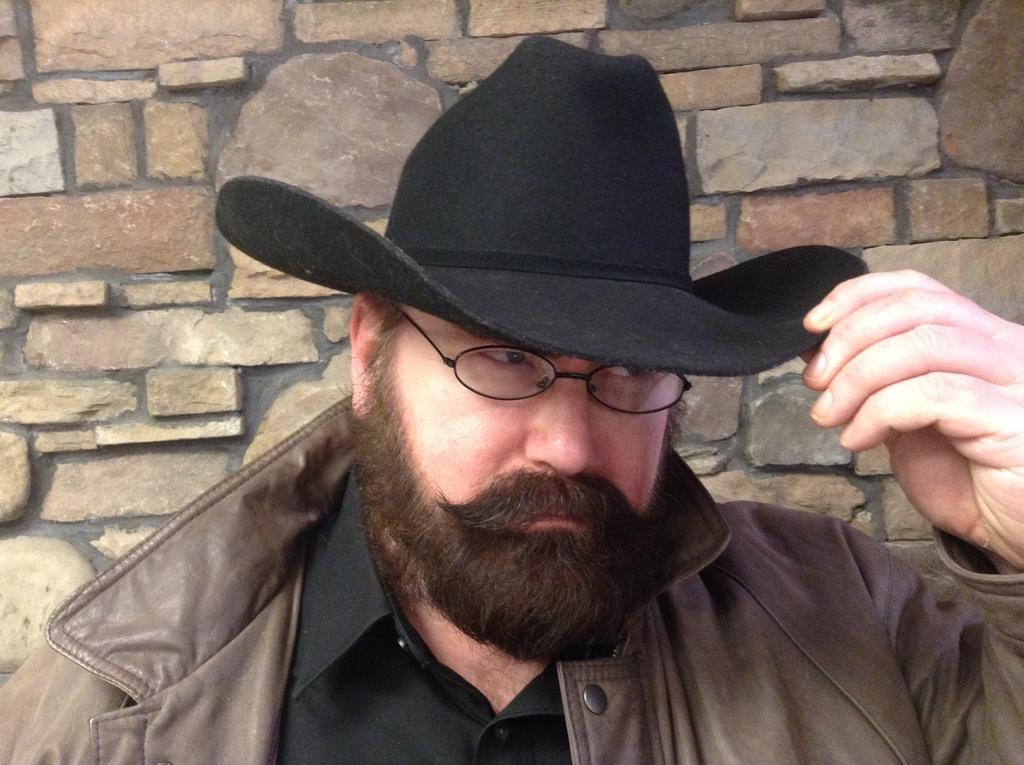Who or what is present in the image? There is a person in the image. What is the person wearing on their head? The person is wearing a hat. What is the person doing in the image? The person is staring at something. What can be seen in the background of the image? There is a rock wall in the background of the image. What type of island can be seen in the background of the image? There is no island present in the image; it features a rock wall in the background. What instrument is the person holding in the image? There is no instrument visible in the image; the person is simply wearing a hat and staring at something. 